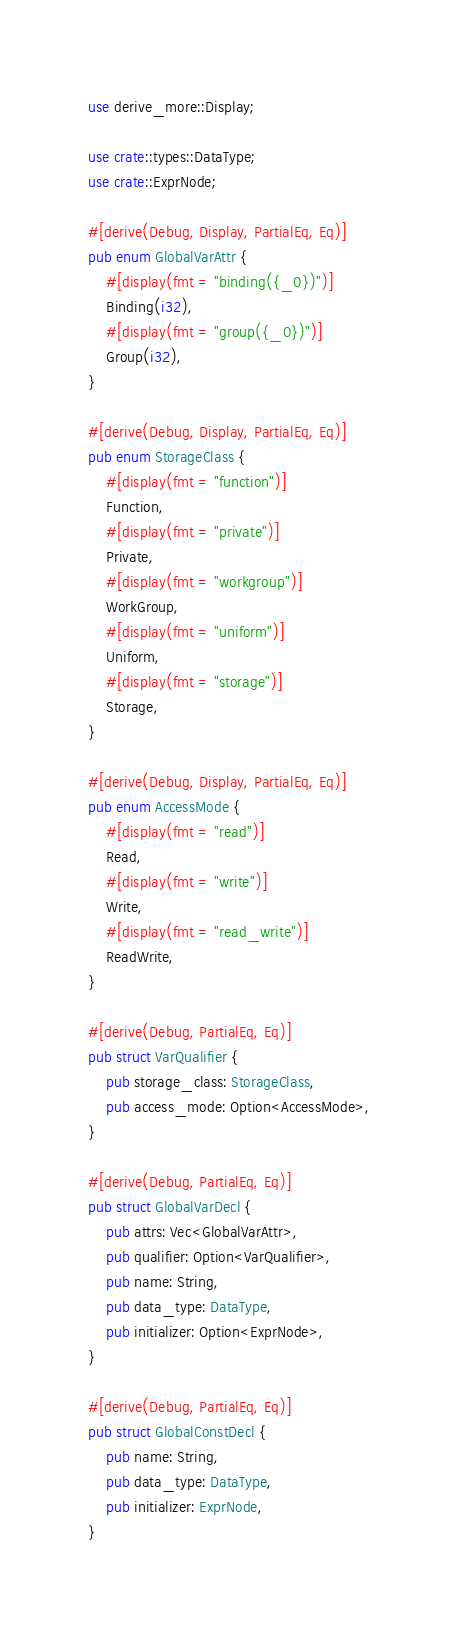<code> <loc_0><loc_0><loc_500><loc_500><_Rust_>use derive_more::Display;

use crate::types::DataType;
use crate::ExprNode;

#[derive(Debug, Display, PartialEq, Eq)]
pub enum GlobalVarAttr {
    #[display(fmt = "binding({_0})")]
    Binding(i32),
    #[display(fmt = "group({_0})")]
    Group(i32),
}

#[derive(Debug, Display, PartialEq, Eq)]
pub enum StorageClass {
    #[display(fmt = "function")]
    Function,
    #[display(fmt = "private")]
    Private,
    #[display(fmt = "workgroup")]
    WorkGroup,
    #[display(fmt = "uniform")]
    Uniform,
    #[display(fmt = "storage")]
    Storage,
}

#[derive(Debug, Display, PartialEq, Eq)]
pub enum AccessMode {
    #[display(fmt = "read")]
    Read,
    #[display(fmt = "write")]
    Write,
    #[display(fmt = "read_write")]
    ReadWrite,
}

#[derive(Debug, PartialEq, Eq)]
pub struct VarQualifier {
    pub storage_class: StorageClass,
    pub access_mode: Option<AccessMode>,
}

#[derive(Debug, PartialEq, Eq)]
pub struct GlobalVarDecl {
    pub attrs: Vec<GlobalVarAttr>,
    pub qualifier: Option<VarQualifier>,
    pub name: String,
    pub data_type: DataType,
    pub initializer: Option<ExprNode>,
}

#[derive(Debug, PartialEq, Eq)]
pub struct GlobalConstDecl {
    pub name: String,
    pub data_type: DataType,
    pub initializer: ExprNode,
}
</code> 